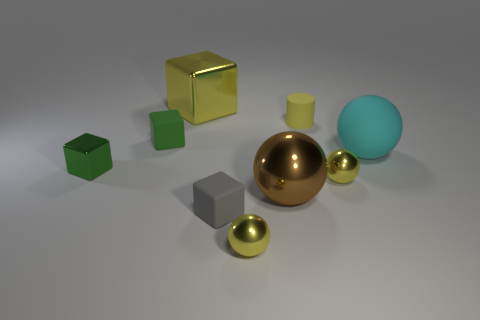How many objects are there in total, and can you categorize them by color? There are a total of seven objects in the scene, which can be categorized by color as follows: two golden/yellow objects, two green objects, a large blue sphere, a large gray cube, and a small sphere that appears to be golden as well. 